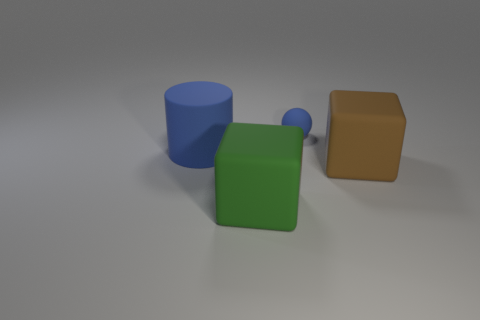There is a object that is the same color as the tiny rubber sphere; what shape is it?
Offer a terse response. Cylinder. Does the sphere have the same size as the block left of the brown cube?
Provide a succinct answer. No. There is a object that is to the right of the green block and behind the big brown rubber object; what color is it?
Ensure brevity in your answer.  Blue. Are there more cylinders that are behind the brown cube than big rubber cubes that are left of the cylinder?
Ensure brevity in your answer.  Yes. The blue cylinder that is the same material as the green object is what size?
Give a very brief answer. Large. How many large blue matte objects are behind the thing on the right side of the rubber ball?
Provide a succinct answer. 1. Are there any other rubber things of the same shape as the big brown thing?
Your answer should be very brief. Yes. What is the color of the cube left of the brown matte object in front of the big cylinder?
Give a very brief answer. Green. Are there more green objects than purple things?
Your answer should be very brief. Yes. How many brown matte things have the same size as the green block?
Provide a succinct answer. 1. 